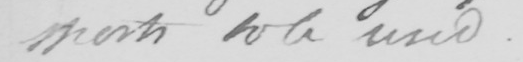Can you tell me what this handwritten text says? sports to be used . 